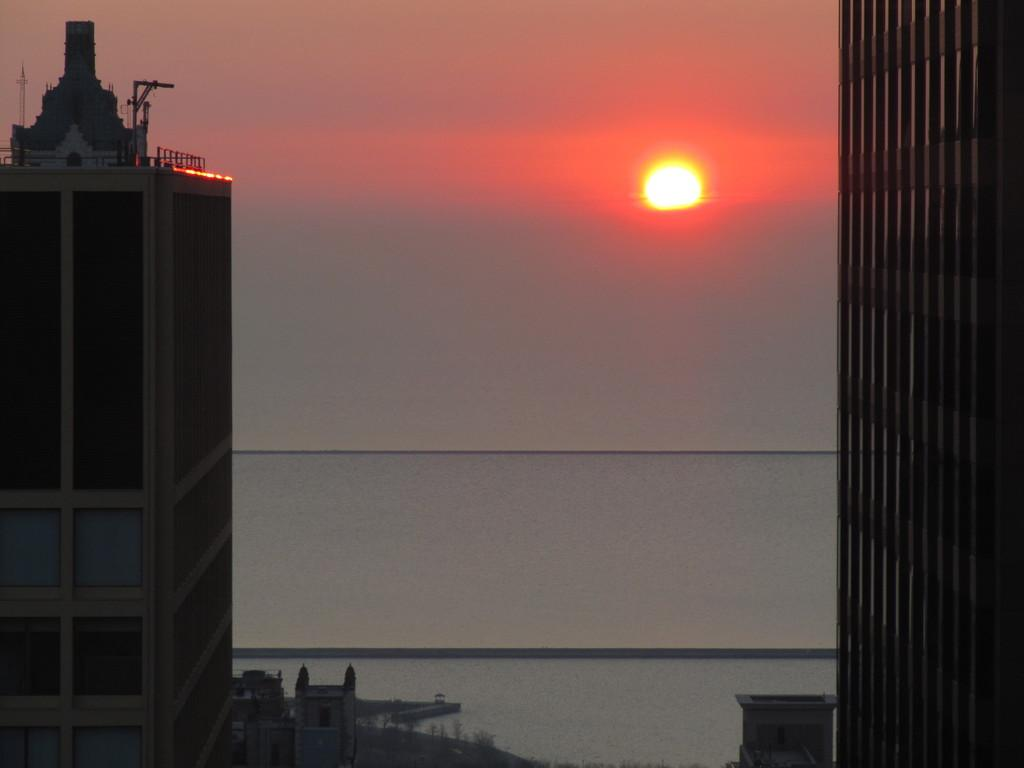What is located on the right side of the image? There are buildings on the right side of the image. What is located on the left side of the image? There are also buildings on the left side of the image. What natural feature can be seen at the bottom of the image? There is an ocean at the bottom of the image. What is visible at the top of the image? The sky is visible at the top of the image. Can you describe the celestial body in the sky? The sun is present in the sky. What type of elbow can be seen in the image? There is no elbow present in the image. What range of colors can be seen in the buildings? The provided facts do not mention the colors of the buildings, so we cannot determine the range of colors in the image. 